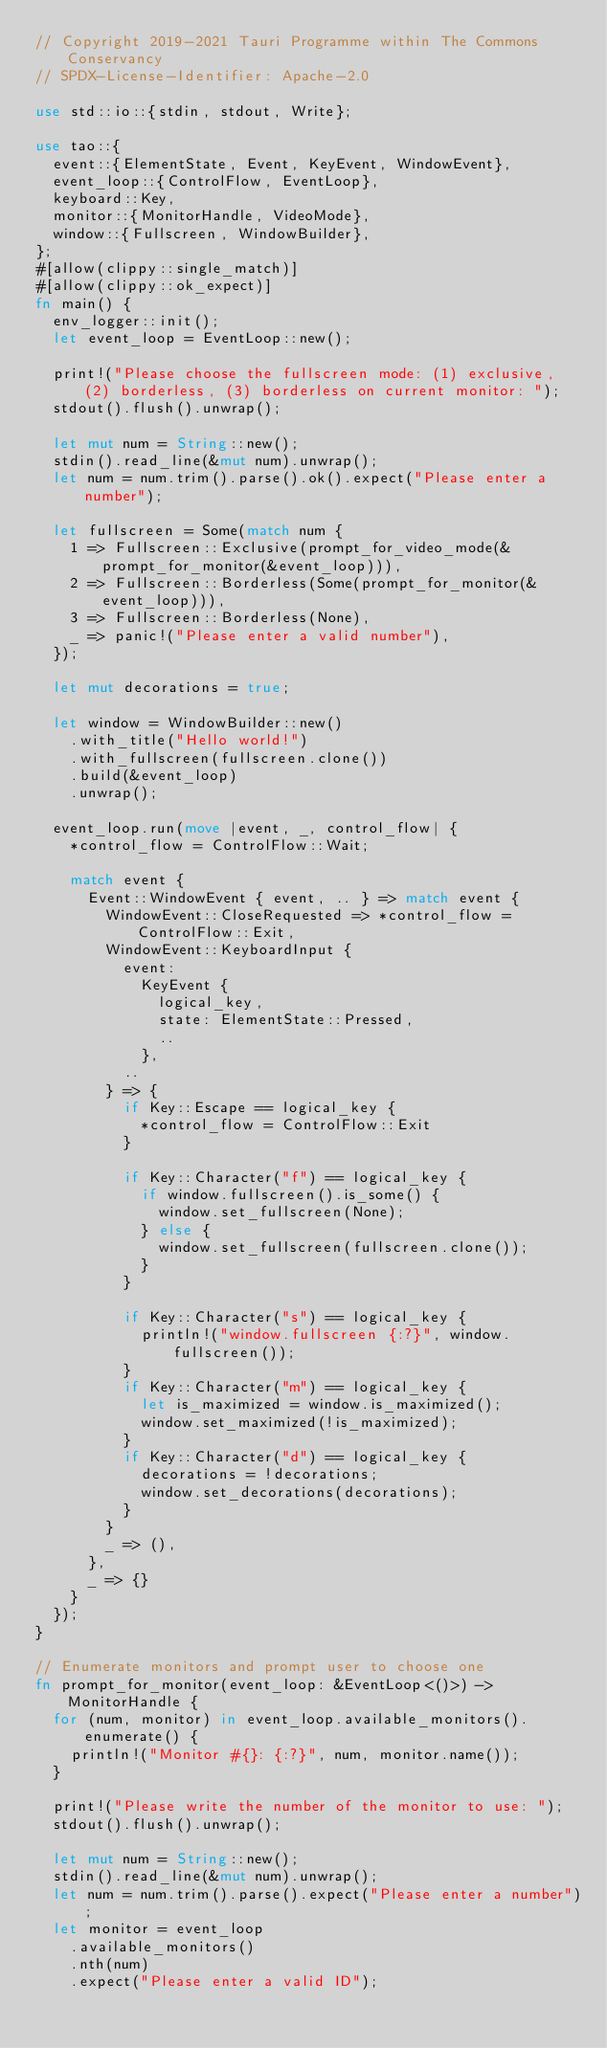<code> <loc_0><loc_0><loc_500><loc_500><_Rust_>// Copyright 2019-2021 Tauri Programme within The Commons Conservancy
// SPDX-License-Identifier: Apache-2.0

use std::io::{stdin, stdout, Write};

use tao::{
  event::{ElementState, Event, KeyEvent, WindowEvent},
  event_loop::{ControlFlow, EventLoop},
  keyboard::Key,
  monitor::{MonitorHandle, VideoMode},
  window::{Fullscreen, WindowBuilder},
};
#[allow(clippy::single_match)]
#[allow(clippy::ok_expect)]
fn main() {
  env_logger::init();
  let event_loop = EventLoop::new();

  print!("Please choose the fullscreen mode: (1) exclusive, (2) borderless, (3) borderless on current monitor: ");
  stdout().flush().unwrap();

  let mut num = String::new();
  stdin().read_line(&mut num).unwrap();
  let num = num.trim().parse().ok().expect("Please enter a number");

  let fullscreen = Some(match num {
    1 => Fullscreen::Exclusive(prompt_for_video_mode(&prompt_for_monitor(&event_loop))),
    2 => Fullscreen::Borderless(Some(prompt_for_monitor(&event_loop))),
    3 => Fullscreen::Borderless(None),
    _ => panic!("Please enter a valid number"),
  });

  let mut decorations = true;

  let window = WindowBuilder::new()
    .with_title("Hello world!")
    .with_fullscreen(fullscreen.clone())
    .build(&event_loop)
    .unwrap();

  event_loop.run(move |event, _, control_flow| {
    *control_flow = ControlFlow::Wait;

    match event {
      Event::WindowEvent { event, .. } => match event {
        WindowEvent::CloseRequested => *control_flow = ControlFlow::Exit,
        WindowEvent::KeyboardInput {
          event:
            KeyEvent {
              logical_key,
              state: ElementState::Pressed,
              ..
            },
          ..
        } => {
          if Key::Escape == logical_key {
            *control_flow = ControlFlow::Exit
          }

          if Key::Character("f") == logical_key {
            if window.fullscreen().is_some() {
              window.set_fullscreen(None);
            } else {
              window.set_fullscreen(fullscreen.clone());
            }
          }

          if Key::Character("s") == logical_key {
            println!("window.fullscreen {:?}", window.fullscreen());
          }
          if Key::Character("m") == logical_key {
            let is_maximized = window.is_maximized();
            window.set_maximized(!is_maximized);
          }
          if Key::Character("d") == logical_key {
            decorations = !decorations;
            window.set_decorations(decorations);
          }
        }
        _ => (),
      },
      _ => {}
    }
  });
}

// Enumerate monitors and prompt user to choose one
fn prompt_for_monitor(event_loop: &EventLoop<()>) -> MonitorHandle {
  for (num, monitor) in event_loop.available_monitors().enumerate() {
    println!("Monitor #{}: {:?}", num, monitor.name());
  }

  print!("Please write the number of the monitor to use: ");
  stdout().flush().unwrap();

  let mut num = String::new();
  stdin().read_line(&mut num).unwrap();
  let num = num.trim().parse().expect("Please enter a number");
  let monitor = event_loop
    .available_monitors()
    .nth(num)
    .expect("Please enter a valid ID");
</code> 